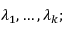Convert formula to latex. <formula><loc_0><loc_0><loc_500><loc_500>\lambda _ { 1 } , \dots , \lambda _ { k } ;</formula> 